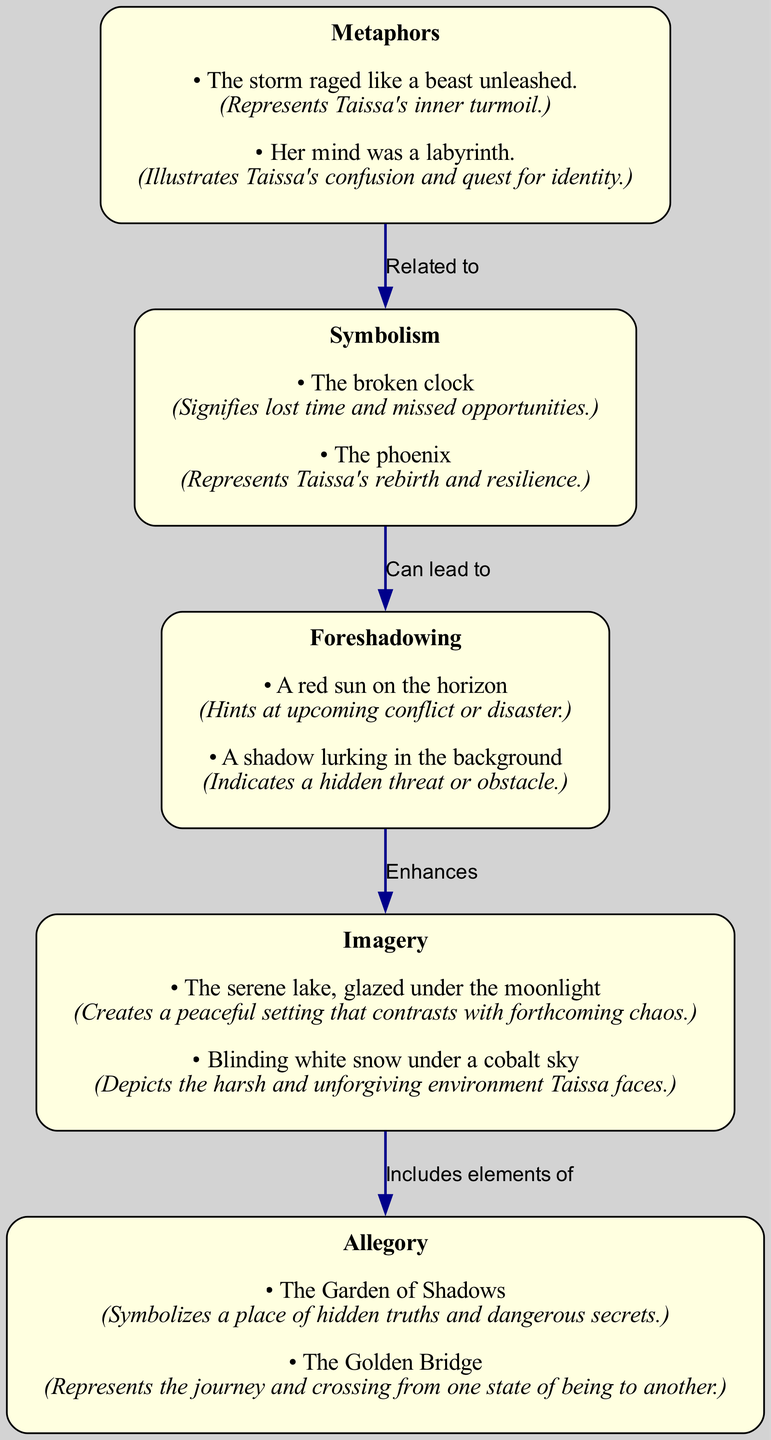What is the first literary device listed in the diagram? The diagram starts with the node labeled "Metaphors," which is at the top of the visual structure, indicating it is the first device detailed.
Answer: Metaphors How many examples of symbolism are presented? In the symbolism node, there are two examples shown, which can be counted directly from the node's content.
Answer: 2 What literary device is described as indicating a hidden threat? The examples in the foreshadowing node include "A shadow lurking in the background," which describes a hidden threat, clarifying the meaning of the device.
Answer: Foreshadowing Which literary device includes elements of imagery? The edge leading from the imagery node to the allegory node denotes that imagery includes elements of allegory, demonstrating a direct connection between these devices in the diagram.
Answer: Allegory What does the broken clock symbolize in Taissa's story? The example under symbolism clearly states that "the broken clock" signifies lost time and missed opportunities, explaining its role in the narrative.
Answer: Lost time and missed opportunities How many edges lead from the metaphors node? The diagram includes one edge leading from the metaphors node to the symbolism node, indicating that it connects directly to only one other device.
Answer: 1 What literary device is related to both symbolism and foreshadowing? The relationship described in the edges shows that symbolism can lead to foreshadowing, thus establishing a connection between these two literary devices.
Answer: Symbolism What does the phrase "the phoenix" represent in the context of Taissa's story? It is detailed under the symbolism examples that "the phoenix" represents Taissa's rebirth and resilience, offering insight into its thematic significance.
Answer: Rebirth and resilience 